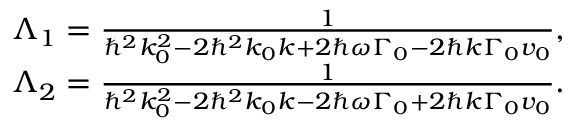<formula> <loc_0><loc_0><loc_500><loc_500>\begin{array} { r } { \Lambda _ { 1 } = { \frac { 1 } { \hbar { ^ } { 2 } k _ { 0 } ^ { 2 } - 2 \hbar { ^ } { 2 } k _ { 0 } k + 2 \hbar { \omega } \Gamma _ { 0 } - 2 \hbar { k } \Gamma _ { 0 } v _ { 0 } } } , } \\ { \Lambda _ { 2 } = { \frac { 1 } { \hbar { ^ } { 2 } k _ { 0 } ^ { 2 } - 2 \hbar { ^ } { 2 } k _ { 0 } k - 2 \hbar { \omega } \Gamma _ { 0 } + 2 \hbar { k } \Gamma _ { 0 } v _ { 0 } } } . } \end{array}</formula> 